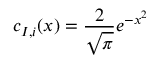Convert formula to latex. <formula><loc_0><loc_0><loc_500><loc_500>c _ { I , i } ( x ) = \frac { 2 } { \sqrt { \pi } } e ^ { - x ^ { 2 } }</formula> 